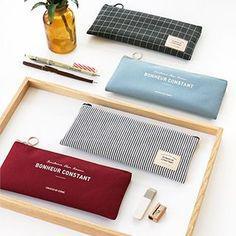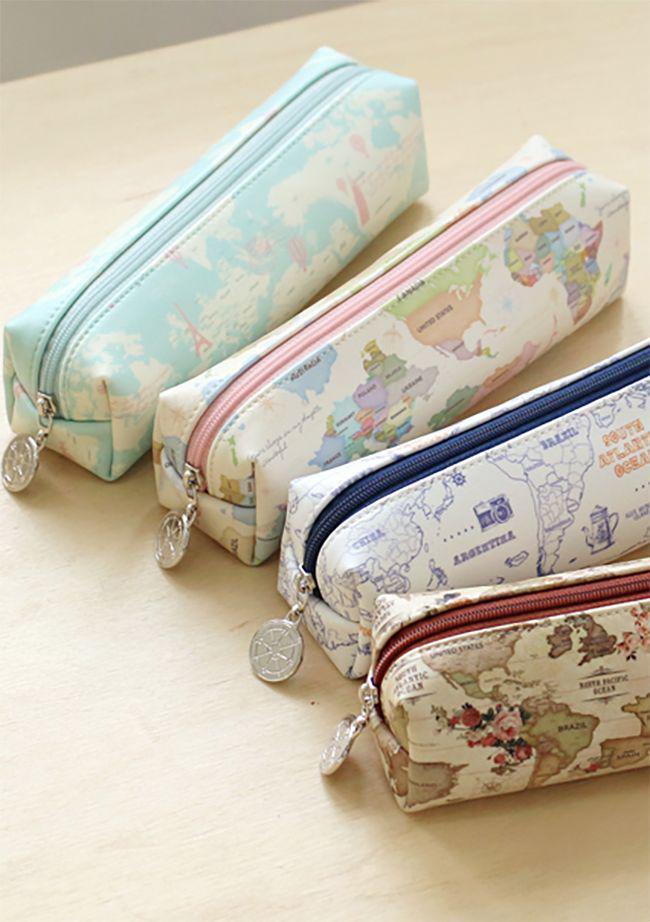The first image is the image on the left, the second image is the image on the right. Analyze the images presented: Is the assertion "There is exactly one open pencil case in the image on the right." valid? Answer yes or no. No. The first image is the image on the left, the second image is the image on the right. For the images displayed, is the sentence "One image features soft-sided tube-shaped pencil cases with a zipper on top." factually correct? Answer yes or no. Yes. 